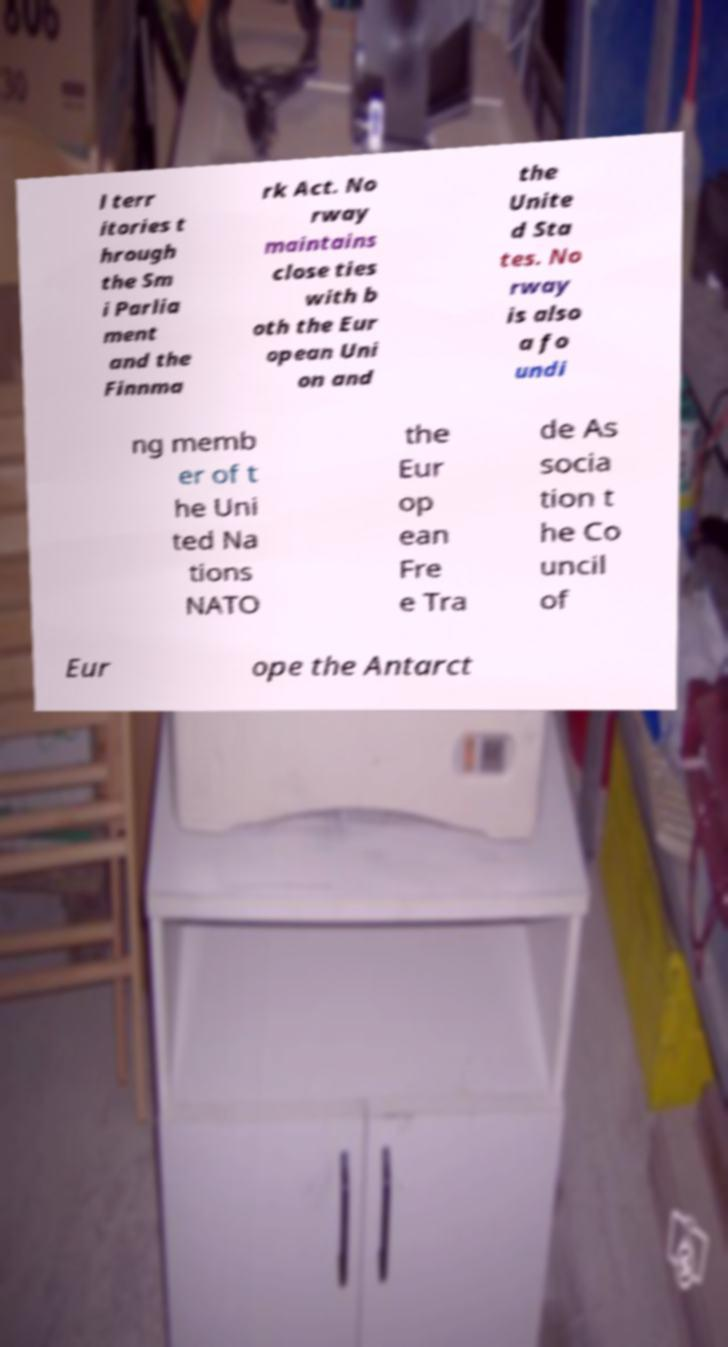Could you extract and type out the text from this image? l terr itories t hrough the Sm i Parlia ment and the Finnma rk Act. No rway maintains close ties with b oth the Eur opean Uni on and the Unite d Sta tes. No rway is also a fo undi ng memb er of t he Uni ted Na tions NATO the Eur op ean Fre e Tra de As socia tion t he Co uncil of Eur ope the Antarct 